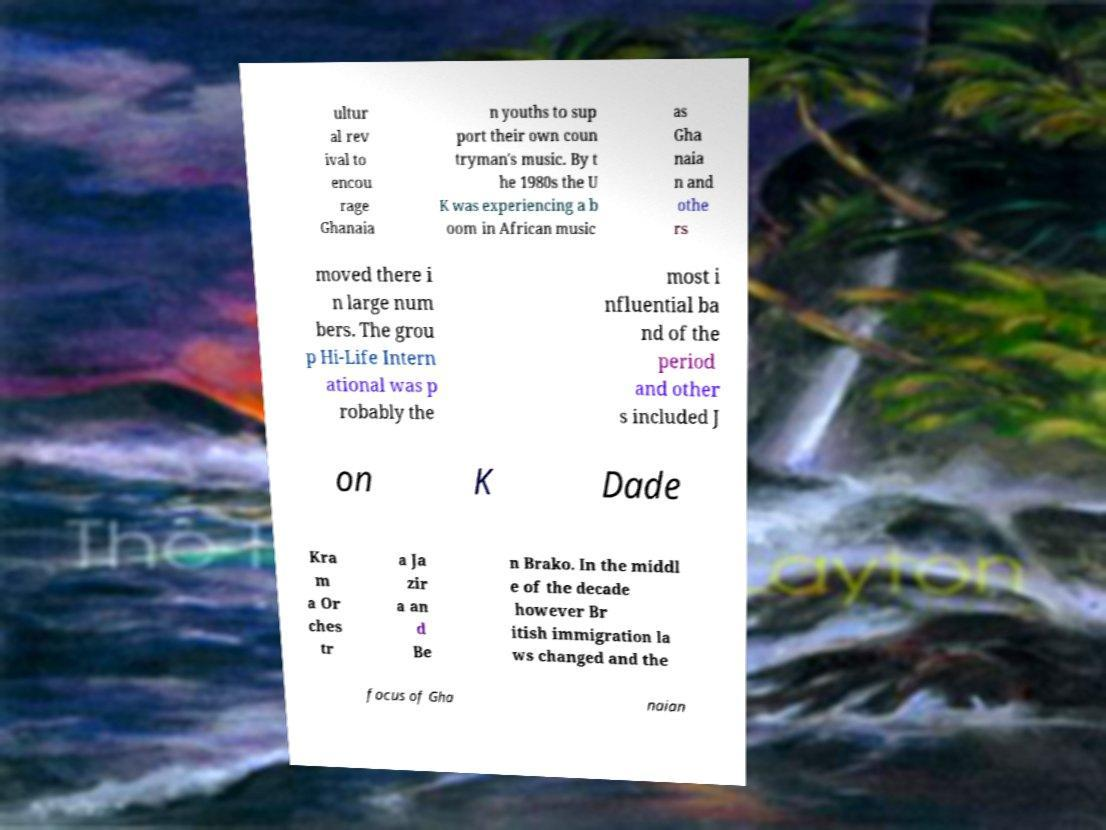Please read and relay the text visible in this image. What does it say? ultur al rev ival to encou rage Ghanaia n youths to sup port their own coun tryman's music. By t he 1980s the U K was experiencing a b oom in African music as Gha naia n and othe rs moved there i n large num bers. The grou p Hi-Life Intern ational was p robably the most i nfluential ba nd of the period and other s included J on K Dade Kra m a Or ches tr a Ja zir a an d Be n Brako. In the middl e of the decade however Br itish immigration la ws changed and the focus of Gha naian 